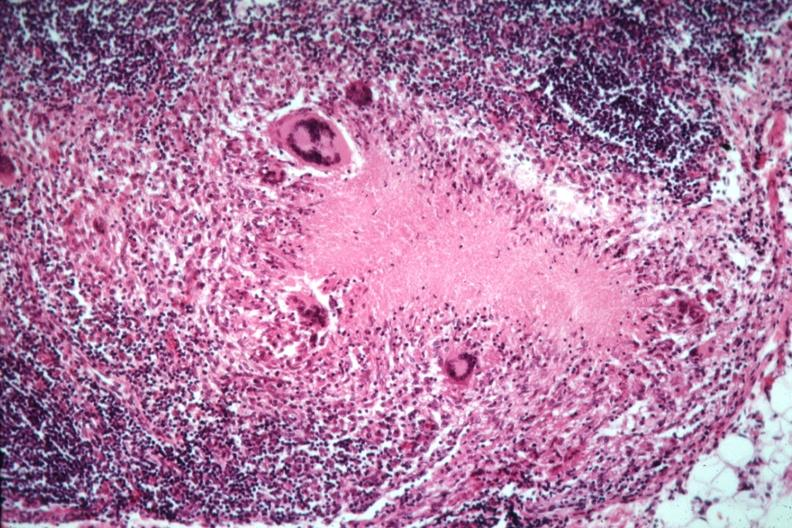does rocky mountain show good example necrotizing granuloma with giant cells?
Answer the question using a single word or phrase. No 